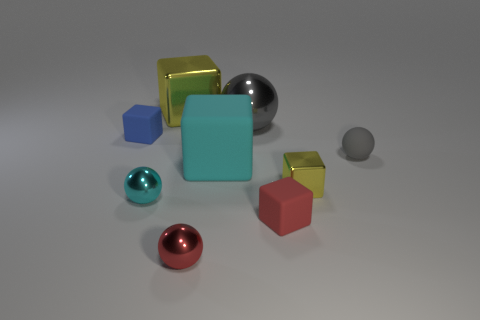Subtract all tiny cubes. How many cubes are left? 2 Subtract all purple cylinders. How many gray balls are left? 2 Add 1 small red objects. How many objects exist? 10 Subtract all red cubes. How many cubes are left? 4 Subtract 2 cubes. How many cubes are left? 3 Subtract all balls. How many objects are left? 5 Subtract all gray spheres. Subtract all purple cylinders. How many spheres are left? 2 Subtract all cyan cubes. Subtract all gray metal things. How many objects are left? 7 Add 8 yellow metal cubes. How many yellow metal cubes are left? 10 Add 4 gray objects. How many gray objects exist? 6 